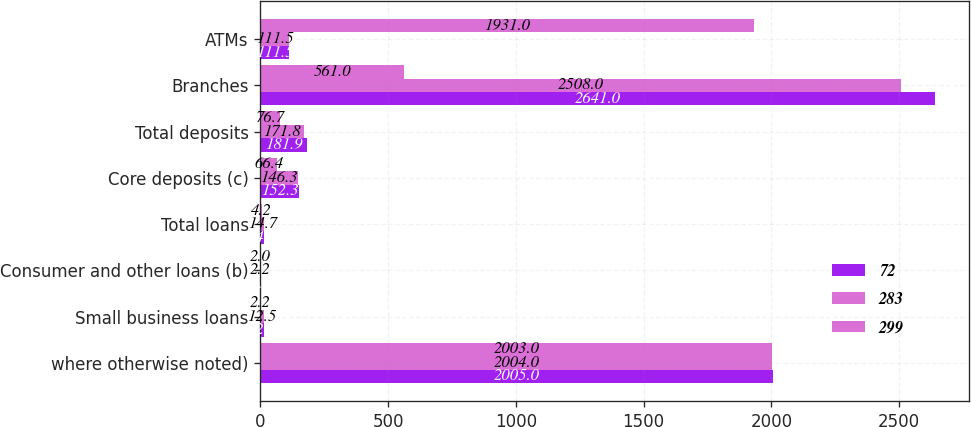<chart> <loc_0><loc_0><loc_500><loc_500><stacked_bar_chart><ecel><fcel>where otherwise noted)<fcel>Small business loans<fcel>Consumer and other loans (b)<fcel>Total loans<fcel>Core deposits (c)<fcel>Total deposits<fcel>Branches<fcel>ATMs<nl><fcel>72<fcel>2005<fcel>12.7<fcel>1.7<fcel>14.4<fcel>152.3<fcel>181.9<fcel>2641<fcel>111.5<nl><fcel>283<fcel>2004<fcel>12.5<fcel>2.2<fcel>14.7<fcel>146.3<fcel>171.8<fcel>2508<fcel>111.5<nl><fcel>299<fcel>2003<fcel>2.2<fcel>2<fcel>4.2<fcel>66.4<fcel>76.7<fcel>561<fcel>1931<nl></chart> 